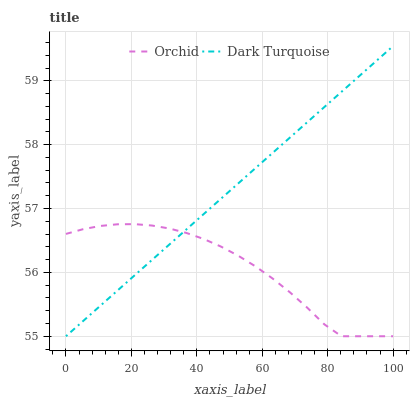Does Orchid have the minimum area under the curve?
Answer yes or no. Yes. Does Dark Turquoise have the maximum area under the curve?
Answer yes or no. Yes. Does Orchid have the maximum area under the curve?
Answer yes or no. No. Is Dark Turquoise the smoothest?
Answer yes or no. Yes. Is Orchid the roughest?
Answer yes or no. Yes. Is Orchid the smoothest?
Answer yes or no. No. Does Dark Turquoise have the lowest value?
Answer yes or no. Yes. Does Dark Turquoise have the highest value?
Answer yes or no. Yes. Does Orchid have the highest value?
Answer yes or no. No. Does Orchid intersect Dark Turquoise?
Answer yes or no. Yes. Is Orchid less than Dark Turquoise?
Answer yes or no. No. Is Orchid greater than Dark Turquoise?
Answer yes or no. No. 